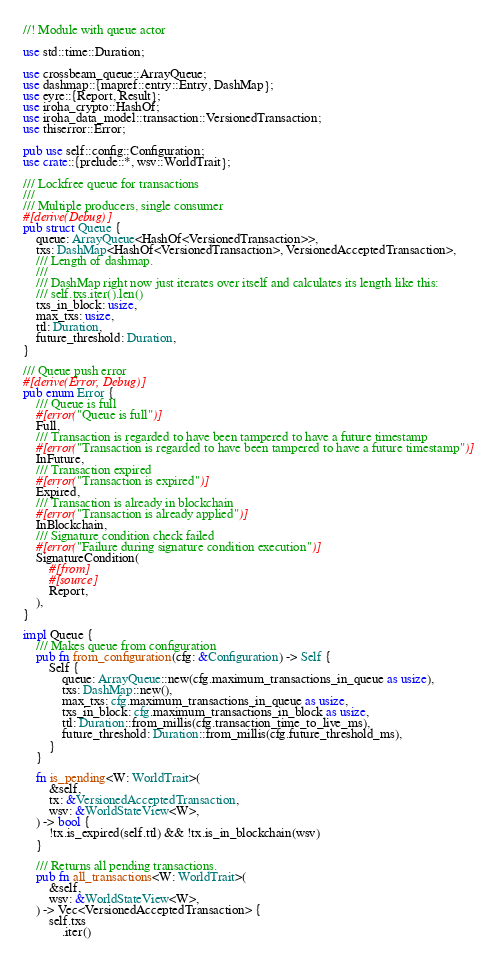Convert code to text. <code><loc_0><loc_0><loc_500><loc_500><_Rust_>//! Module with queue actor

use std::time::Duration;

use crossbeam_queue::ArrayQueue;
use dashmap::{mapref::entry::Entry, DashMap};
use eyre::{Report, Result};
use iroha_crypto::HashOf;
use iroha_data_model::transaction::VersionedTransaction;
use thiserror::Error;

pub use self::config::Configuration;
use crate::{prelude::*, wsv::WorldTrait};

/// Lockfree queue for transactions
///
/// Multiple producers, single consumer
#[derive(Debug)]
pub struct Queue {
    queue: ArrayQueue<HashOf<VersionedTransaction>>,
    txs: DashMap<HashOf<VersionedTransaction>, VersionedAcceptedTransaction>,
    /// Length of dashmap.
    ///
    /// DashMap right now just iterates over itself and calculates its length like this:
    /// self.txs.iter().len()
    txs_in_block: usize,
    max_txs: usize,
    ttl: Duration,
    future_threshold: Duration,
}

/// Queue push error
#[derive(Error, Debug)]
pub enum Error {
    /// Queue is full
    #[error("Queue is full")]
    Full,
    /// Transaction is regarded to have been tampered to have a future timestamp
    #[error("Transaction is regarded to have been tampered to have a future timestamp")]
    InFuture,
    /// Transaction expired
    #[error("Transaction is expired")]
    Expired,
    /// Transaction is already in blockchain
    #[error("Transaction is already applied")]
    InBlockchain,
    /// Signature condition check failed
    #[error("Failure during signature condition execution")]
    SignatureCondition(
        #[from]
        #[source]
        Report,
    ),
}

impl Queue {
    /// Makes queue from configuration
    pub fn from_configuration(cfg: &Configuration) -> Self {
        Self {
            queue: ArrayQueue::new(cfg.maximum_transactions_in_queue as usize),
            txs: DashMap::new(),
            max_txs: cfg.maximum_transactions_in_queue as usize,
            txs_in_block: cfg.maximum_transactions_in_block as usize,
            ttl: Duration::from_millis(cfg.transaction_time_to_live_ms),
            future_threshold: Duration::from_millis(cfg.future_threshold_ms),
        }
    }

    fn is_pending<W: WorldTrait>(
        &self,
        tx: &VersionedAcceptedTransaction,
        wsv: &WorldStateView<W>,
    ) -> bool {
        !tx.is_expired(self.ttl) && !tx.is_in_blockchain(wsv)
    }

    /// Returns all pending transactions.
    pub fn all_transactions<W: WorldTrait>(
        &self,
        wsv: &WorldStateView<W>,
    ) -> Vec<VersionedAcceptedTransaction> {
        self.txs
            .iter()</code> 